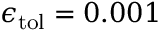Convert formula to latex. <formula><loc_0><loc_0><loc_500><loc_500>\epsilon _ { t o l } = 0 . 0 0 1 \</formula> 